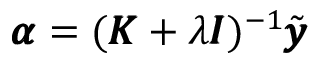<formula> <loc_0><loc_0><loc_500><loc_500>\pm b { \alpha } = ( \pm b { K } + \lambda \pm b { I } ) ^ { - 1 } \tilde { \pm b { y } }</formula> 